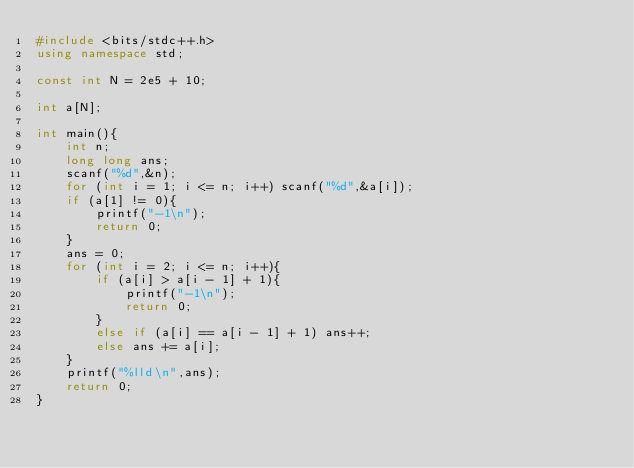Convert code to text. <code><loc_0><loc_0><loc_500><loc_500><_C++_>#include <bits/stdc++.h>
using namespace std;

const int N = 2e5 + 10;

int a[N];

int main(){
	int n;
	long long ans;
	scanf("%d",&n);
	for (int i = 1; i <= n; i++) scanf("%d",&a[i]);
	if (a[1] != 0){
		printf("-1\n");
		return 0;
	}
	ans = 0;
	for (int i = 2; i <= n; i++){
		if (a[i] > a[i - 1] + 1){
			printf("-1\n");
			return 0;
		}
		else if (a[i] == a[i - 1] + 1) ans++;
		else ans += a[i];
	}
	printf("%lld\n",ans);
	return 0;
} </code> 